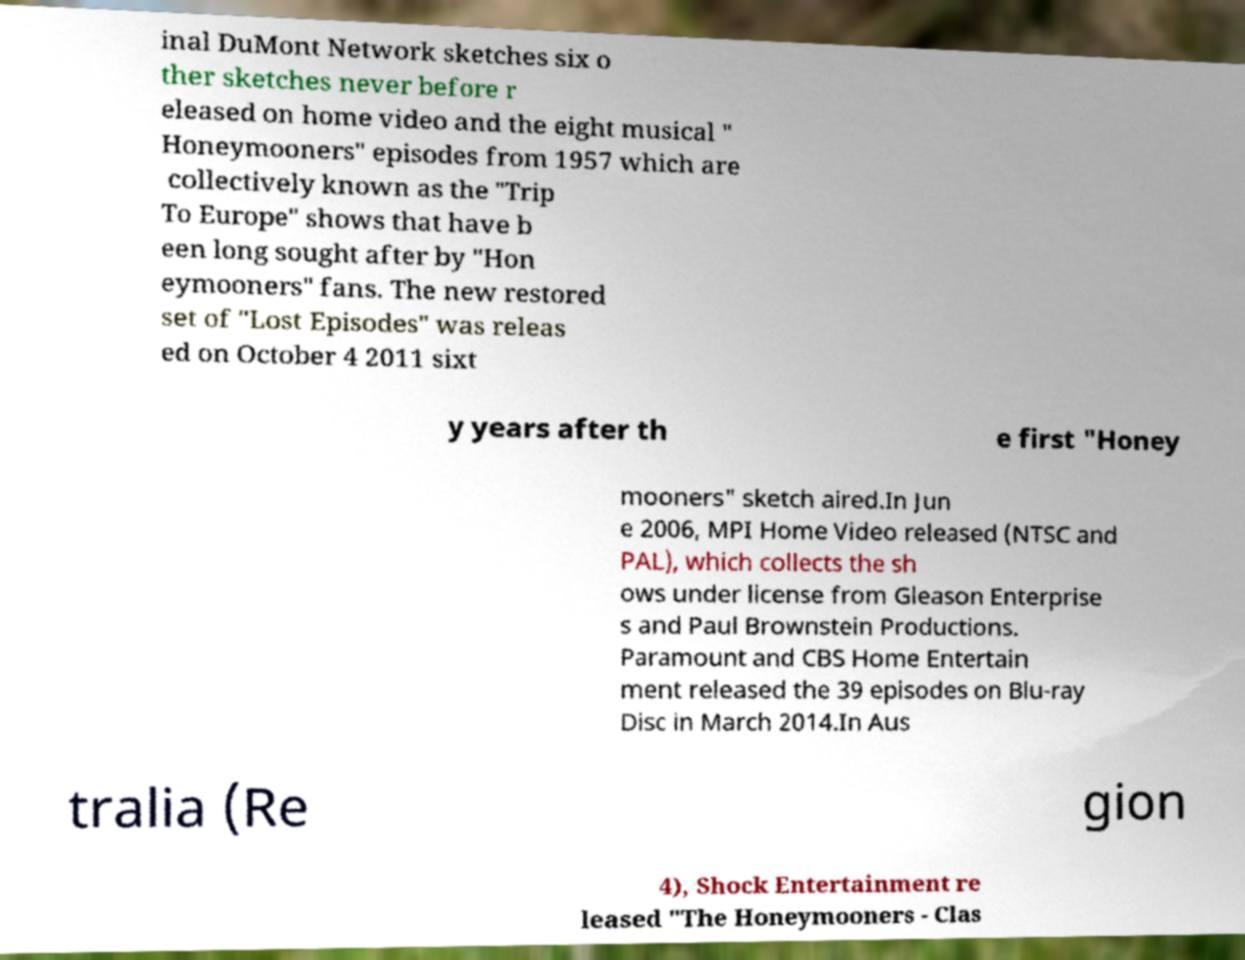Can you read and provide the text displayed in the image?This photo seems to have some interesting text. Can you extract and type it out for me? inal DuMont Network sketches six o ther sketches never before r eleased on home video and the eight musical " Honeymooners" episodes from 1957 which are collectively known as the "Trip To Europe" shows that have b een long sought after by "Hon eymooners" fans. The new restored set of "Lost Episodes" was releas ed on October 4 2011 sixt y years after th e first "Honey mooners" sketch aired.In Jun e 2006, MPI Home Video released (NTSC and PAL), which collects the sh ows under license from Gleason Enterprise s and Paul Brownstein Productions. Paramount and CBS Home Entertain ment released the 39 episodes on Blu-ray Disc in March 2014.In Aus tralia (Re gion 4), Shock Entertainment re leased "The Honeymooners - Clas 